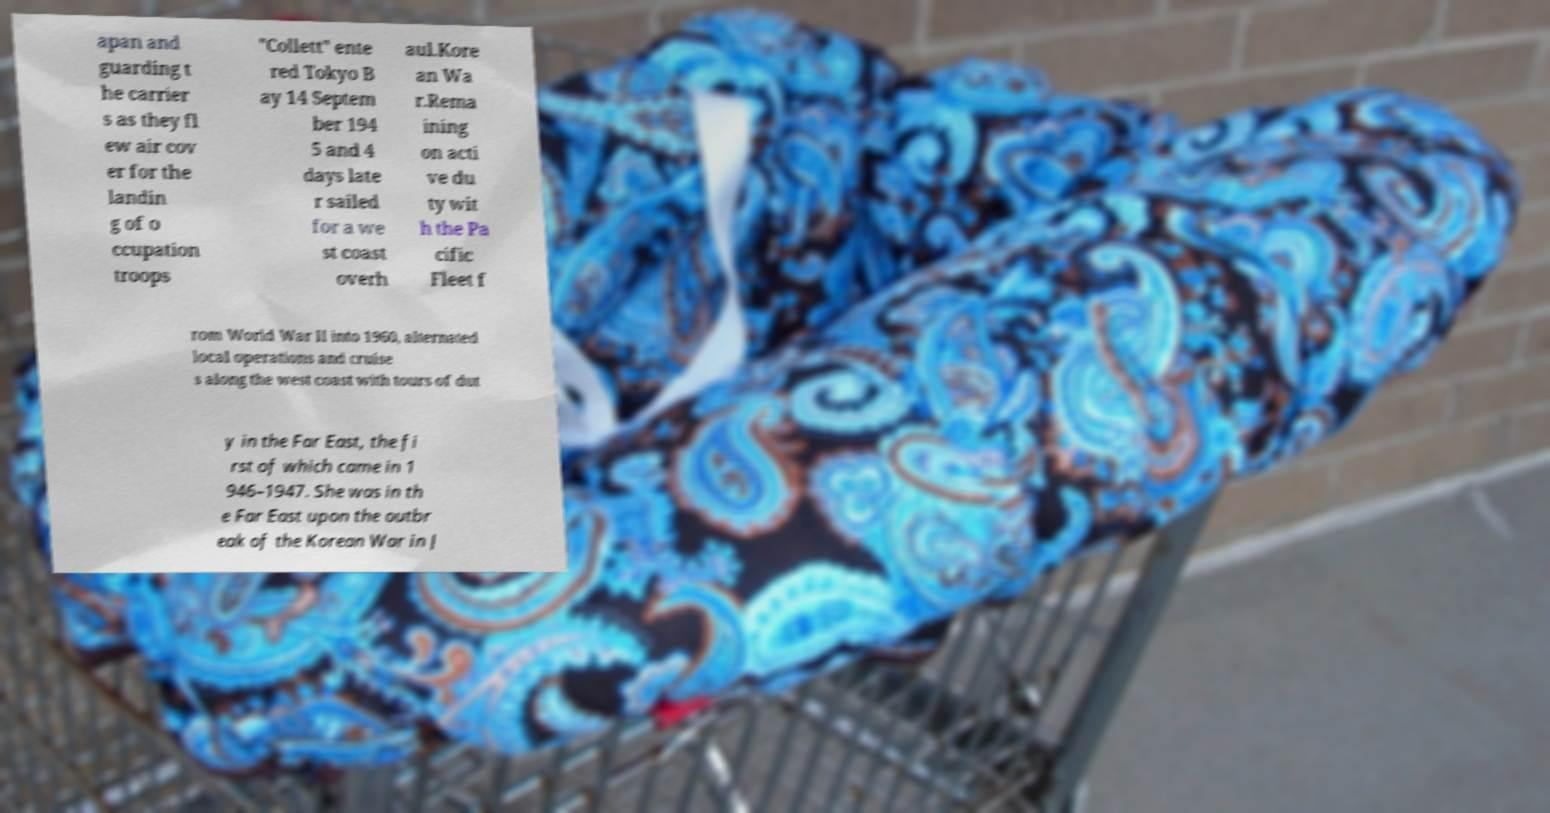Can you accurately transcribe the text from the provided image for me? apan and guarding t he carrier s as they fl ew air cov er for the landin g of o ccupation troops "Collett" ente red Tokyo B ay 14 Septem ber 194 5 and 4 days late r sailed for a we st coast overh aul.Kore an Wa r.Rema ining on acti ve du ty wit h the Pa cific Fleet f rom World War II into 1960, alternated local operations and cruise s along the west coast with tours of dut y in the Far East, the fi rst of which came in 1 946–1947. She was in th e Far East upon the outbr eak of the Korean War in J 